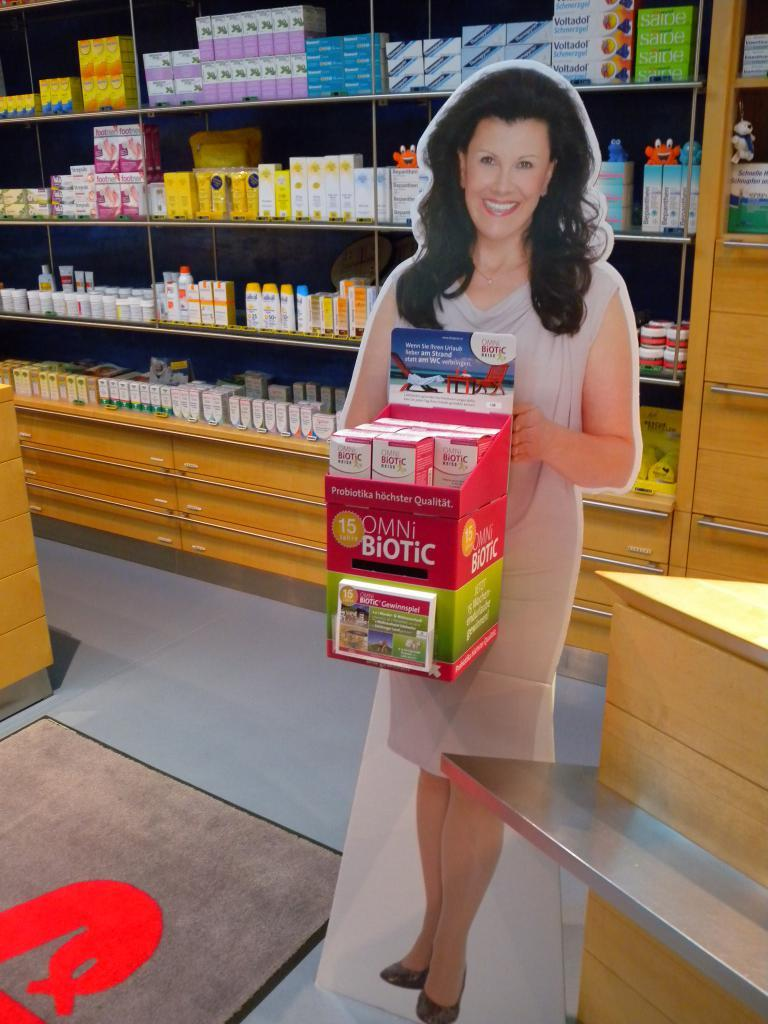<image>
Describe the image concisely. A stand-up of a woman displays an orange box of Omni Biotic. 